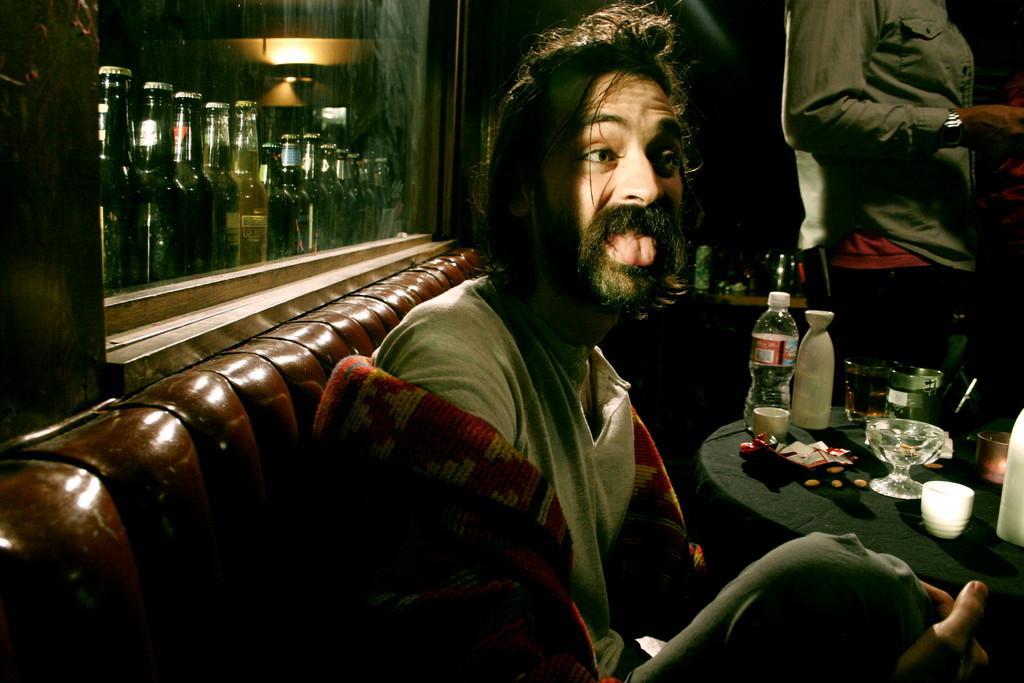In one or two sentences, can you explain what this image depicts? In the middle there is a man he wear t shirt and trouser ,he is sitting on the sofa. On the left there are many bottles. In the middle there is a table on that table there is a bottle ,cup , glass and some other items. On the right there is a person. 